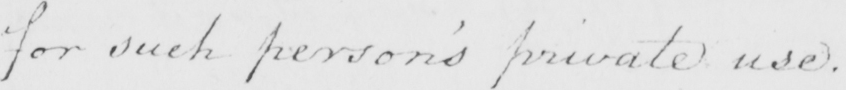Transcribe the text shown in this historical manuscript line. for such person ' s private use . 